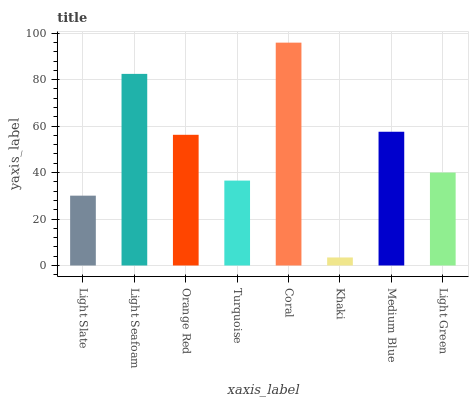Is Khaki the minimum?
Answer yes or no. Yes. Is Coral the maximum?
Answer yes or no. Yes. Is Light Seafoam the minimum?
Answer yes or no. No. Is Light Seafoam the maximum?
Answer yes or no. No. Is Light Seafoam greater than Light Slate?
Answer yes or no. Yes. Is Light Slate less than Light Seafoam?
Answer yes or no. Yes. Is Light Slate greater than Light Seafoam?
Answer yes or no. No. Is Light Seafoam less than Light Slate?
Answer yes or no. No. Is Orange Red the high median?
Answer yes or no. Yes. Is Light Green the low median?
Answer yes or no. Yes. Is Medium Blue the high median?
Answer yes or no. No. Is Coral the low median?
Answer yes or no. No. 